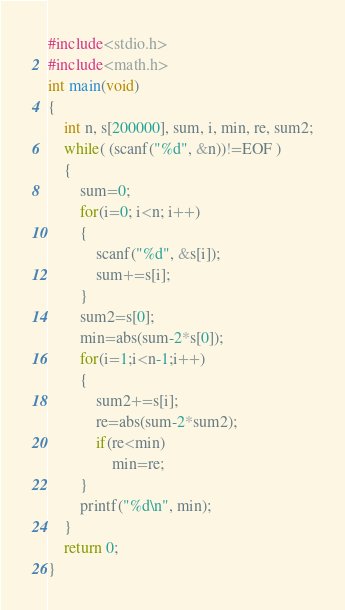Convert code to text. <code><loc_0><loc_0><loc_500><loc_500><_C_>#include<stdio.h>
#include<math.h>
int main(void)
{
    int n, s[200000], sum, i, min, re, sum2;
    while( (scanf("%d", &n))!=EOF )
    {
        sum=0;
        for(i=0; i<n; i++)
        {
            scanf("%d", &s[i]);
            sum+=s[i];
        }
        sum2=s[0];
        min=abs(sum-2*s[0]);
        for(i=1;i<n-1;i++)
        {
            sum2+=s[i];
            re=abs(sum-2*sum2);
            if(re<min)
                min=re;
        }
        printf("%d\n", min);
    }
    return 0;
}</code> 